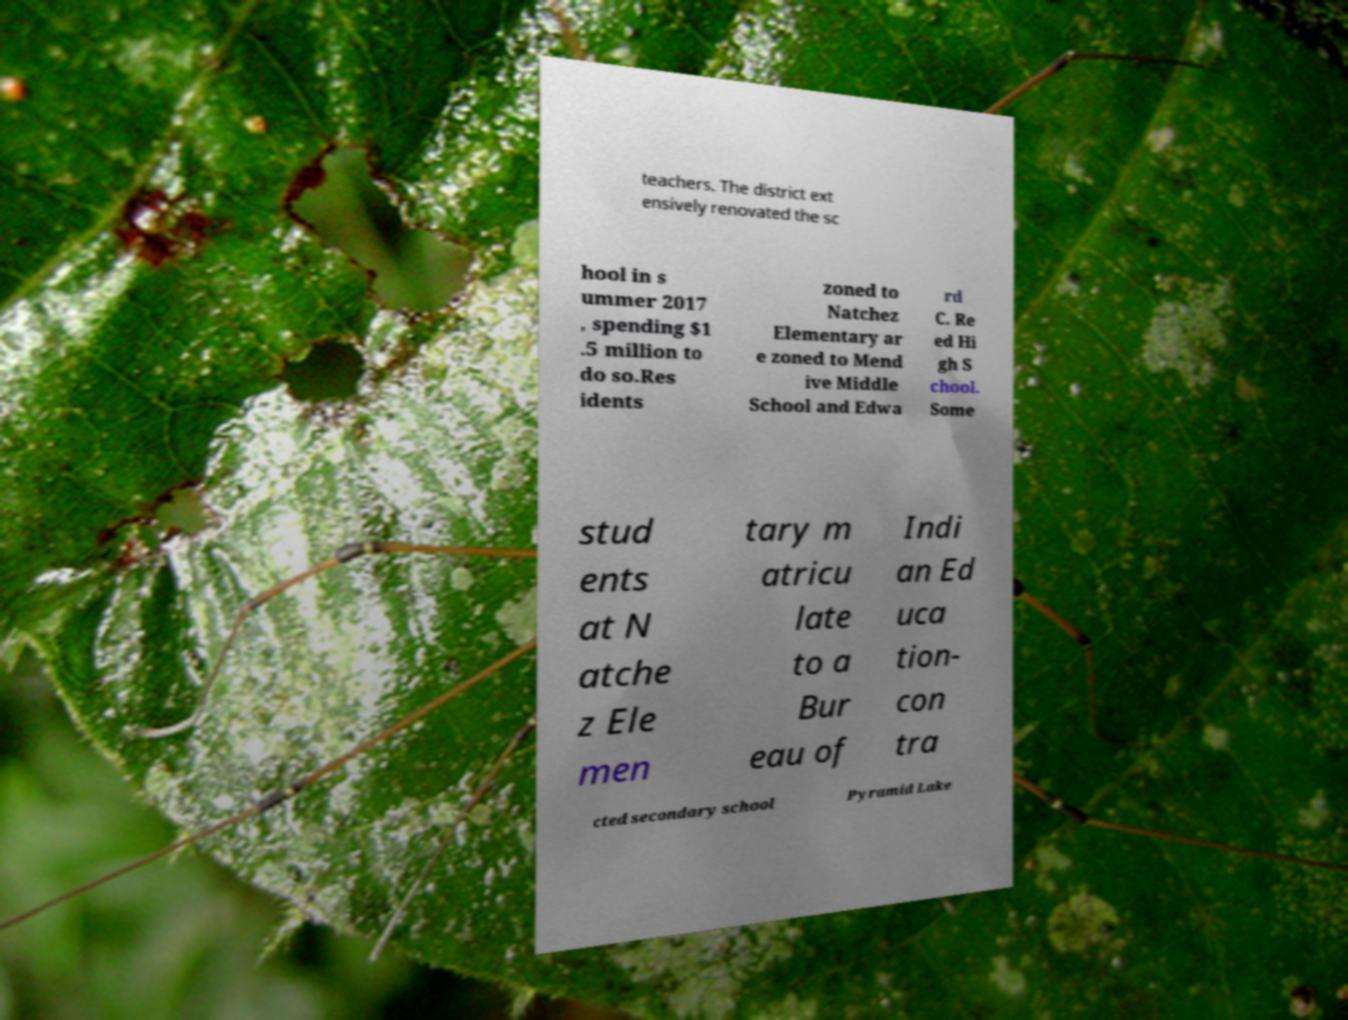Can you read and provide the text displayed in the image?This photo seems to have some interesting text. Can you extract and type it out for me? teachers. The district ext ensively renovated the sc hool in s ummer 2017 , spending $1 .5 million to do so.Res idents zoned to Natchez Elementary ar e zoned to Mend ive Middle School and Edwa rd C. Re ed Hi gh S chool. Some stud ents at N atche z Ele men tary m atricu late to a Bur eau of Indi an Ed uca tion- con tra cted secondary school Pyramid Lake 